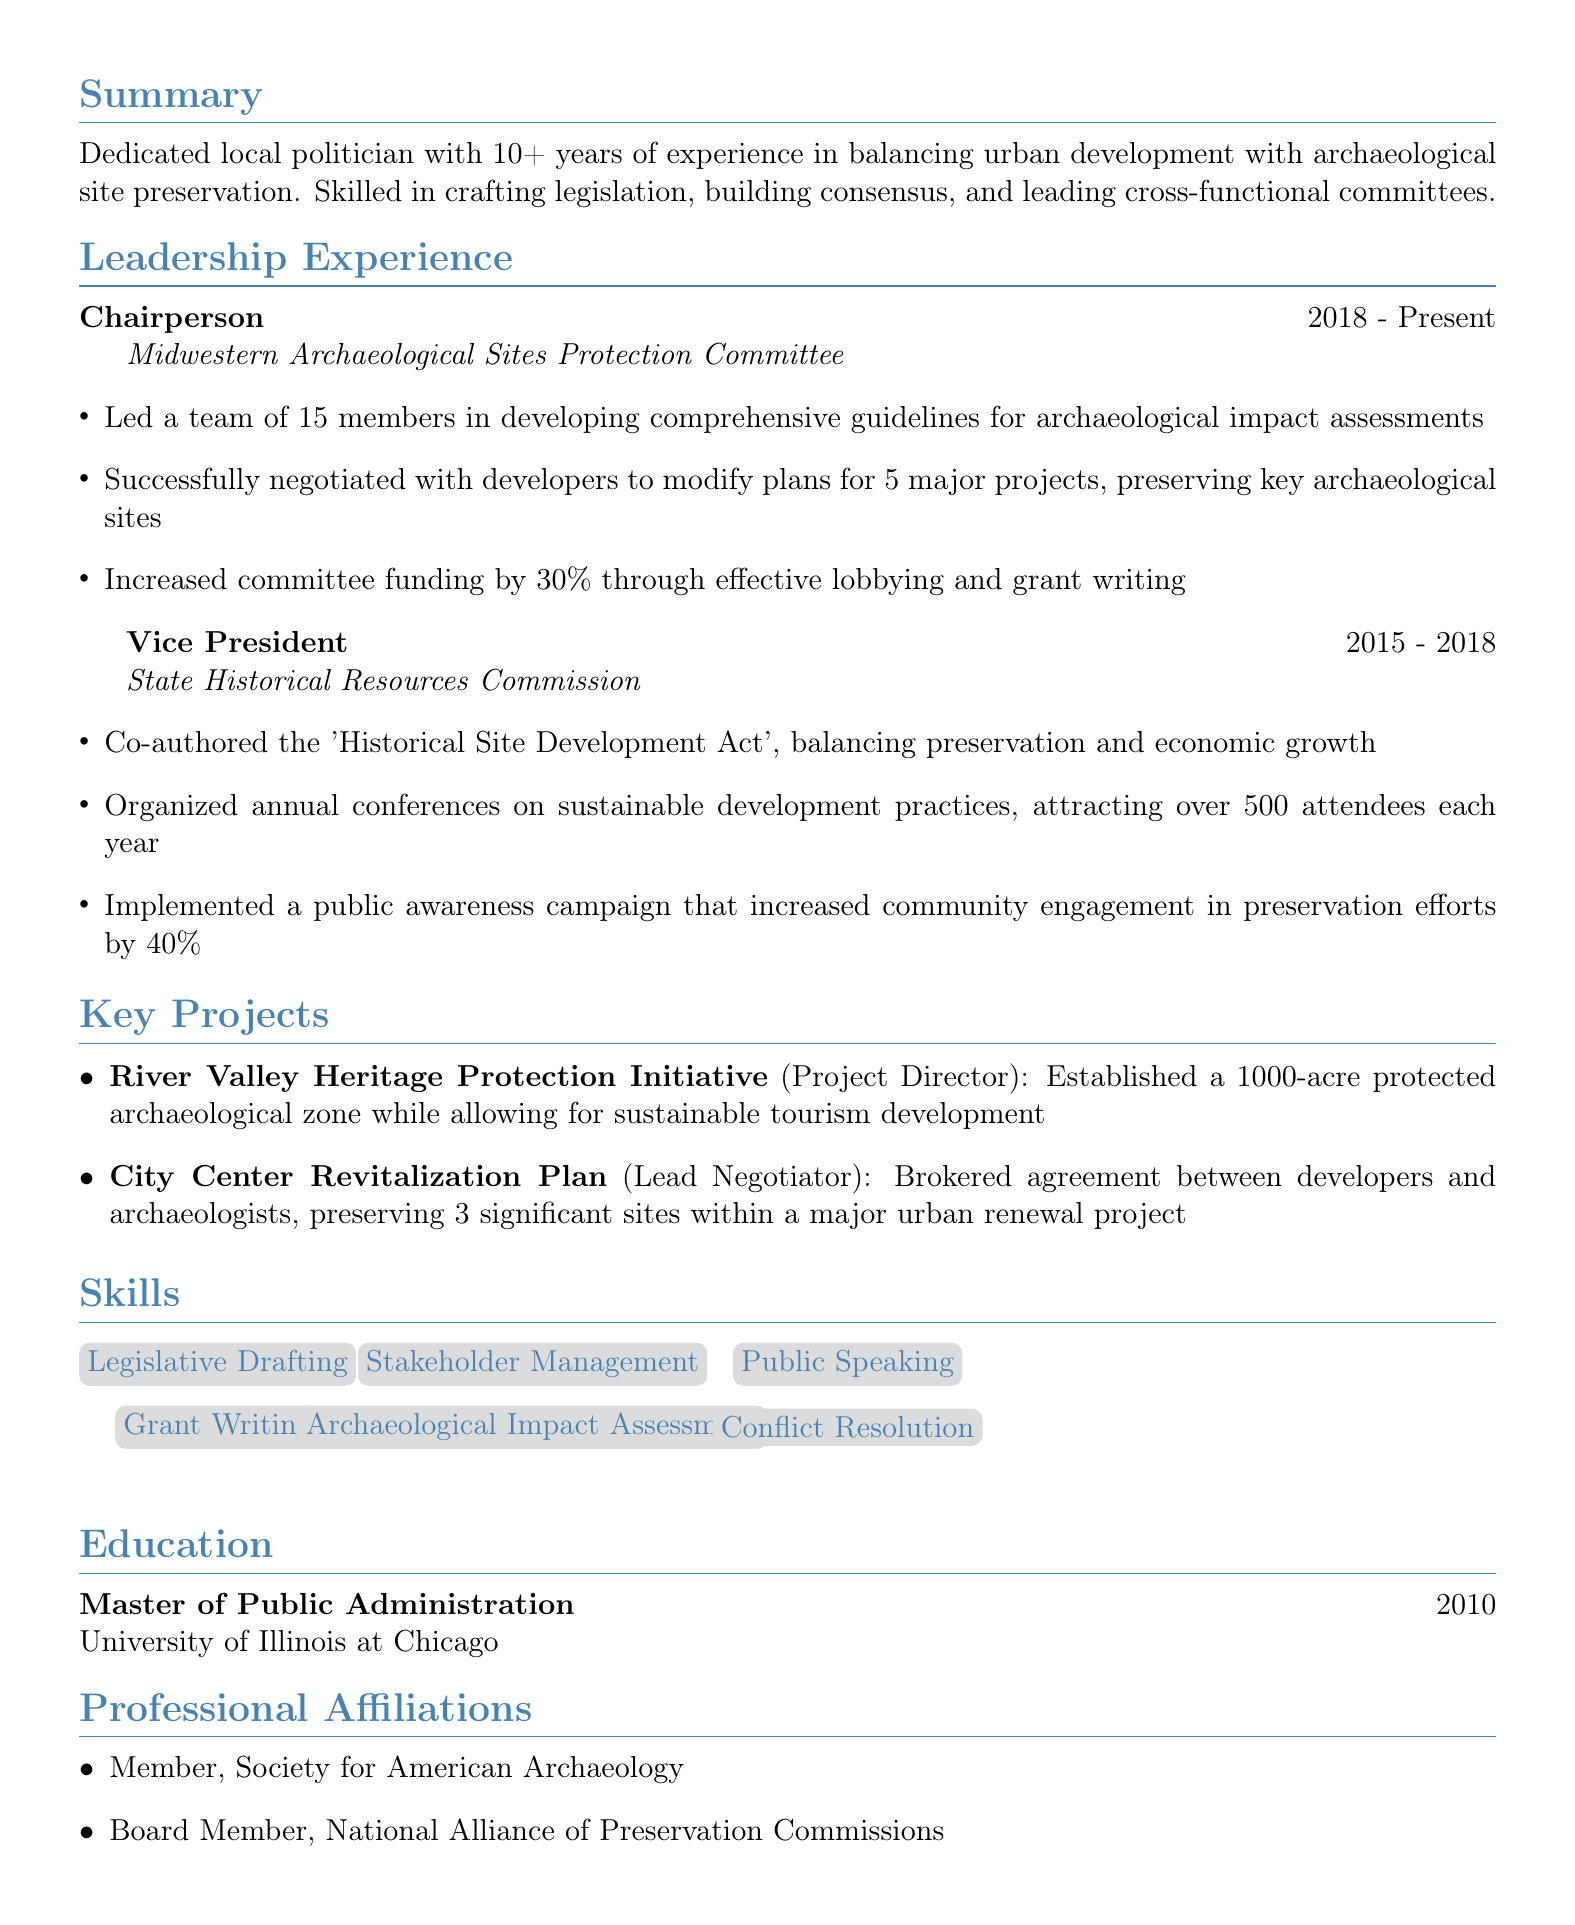What is the title of Sarah J. Thompson? The title is presented at the top of the resume, indicating her current role or position.
Answer: Regional Archaeological Preservation Advocate How many years of experience does Sarah J. Thompson have? The resume summarizes her professional experience, indicating the duration of her career relevant to the field.
Answer: 10+ What organization does Sarah currently chair? The chairperson position is detailed in the leadership experience section, specifying the organization she leads.
Answer: Midwestern Archaeological Sites Protection Committee What significant act did Sarah co-author as Vice President? This is mentioned in the leadership experience to highlight her legislative contributions.
Answer: Historical Site Development Act What was the outcome of the River Valley Heritage Protection Initiative? The key project section outlines significant achievements under her leadership, including the results of her projects.
Answer: Established a 1000-acre protected archaeological zone while allowing for sustainable tourism development How much did Sarah increase committee funding? The leadership experience section provides specific achievements about funding growth in one of her roles.
Answer: 30% What is one of Sarah's key skills? The skills section lists various competencies that she possesses which relate to her professional work.
Answer: Legislative Drafting When did Sarah obtain her Master's degree? The education section specifies the year of her degree, providing context about her academic background.
Answer: 2010 How many members are on the Midwestern Archaeological Sites Protection Committee? The leadership experience section includes details about her team size while describing her role.
Answer: 15 members 